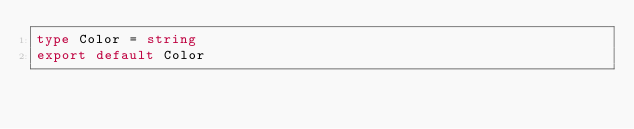Convert code to text. <code><loc_0><loc_0><loc_500><loc_500><_TypeScript_>type Color = string
export default Color</code> 